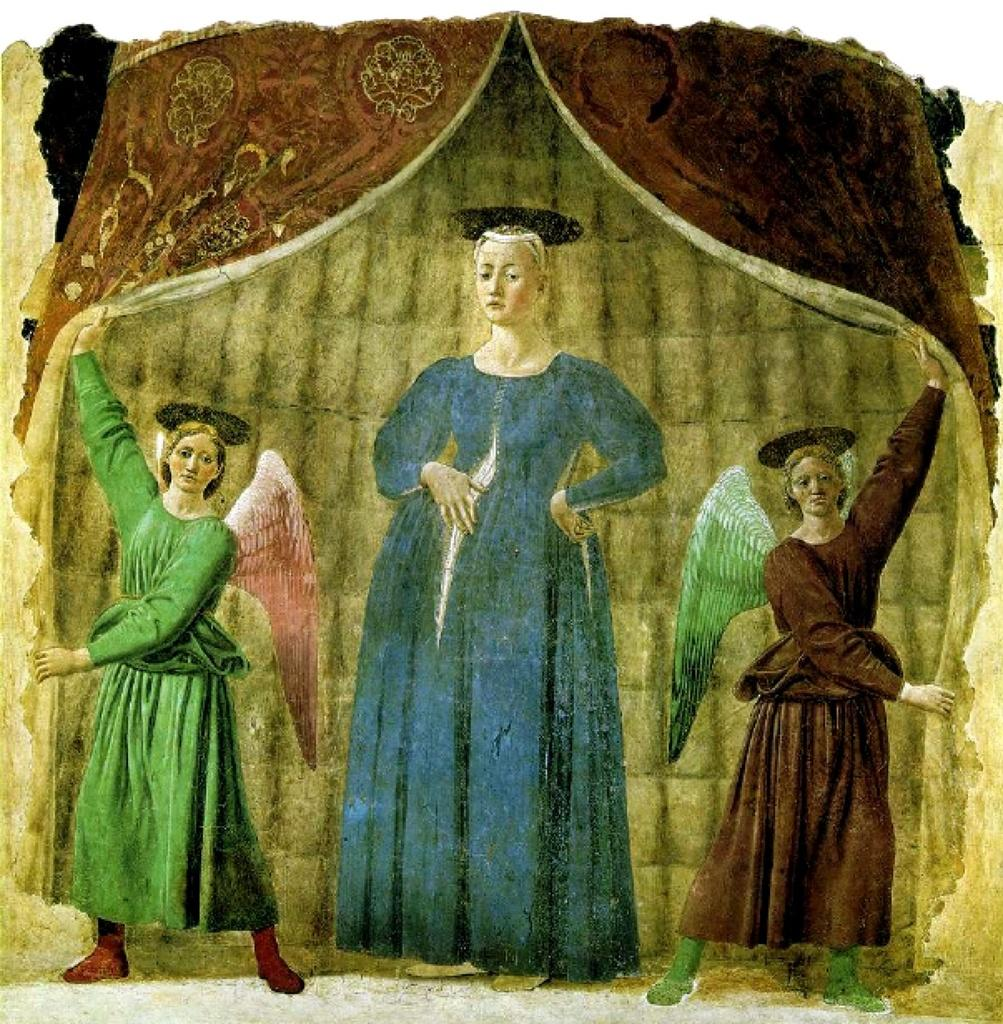What is the main subject of the image? The main subject of the image is a depiction of three women. Can you describe any other elements in the image? Yes, there are curtains in the image. What type of sense or nerve can be seen in the image? There is no sense or nerve present in the image; it features a depiction of three women and curtains. 